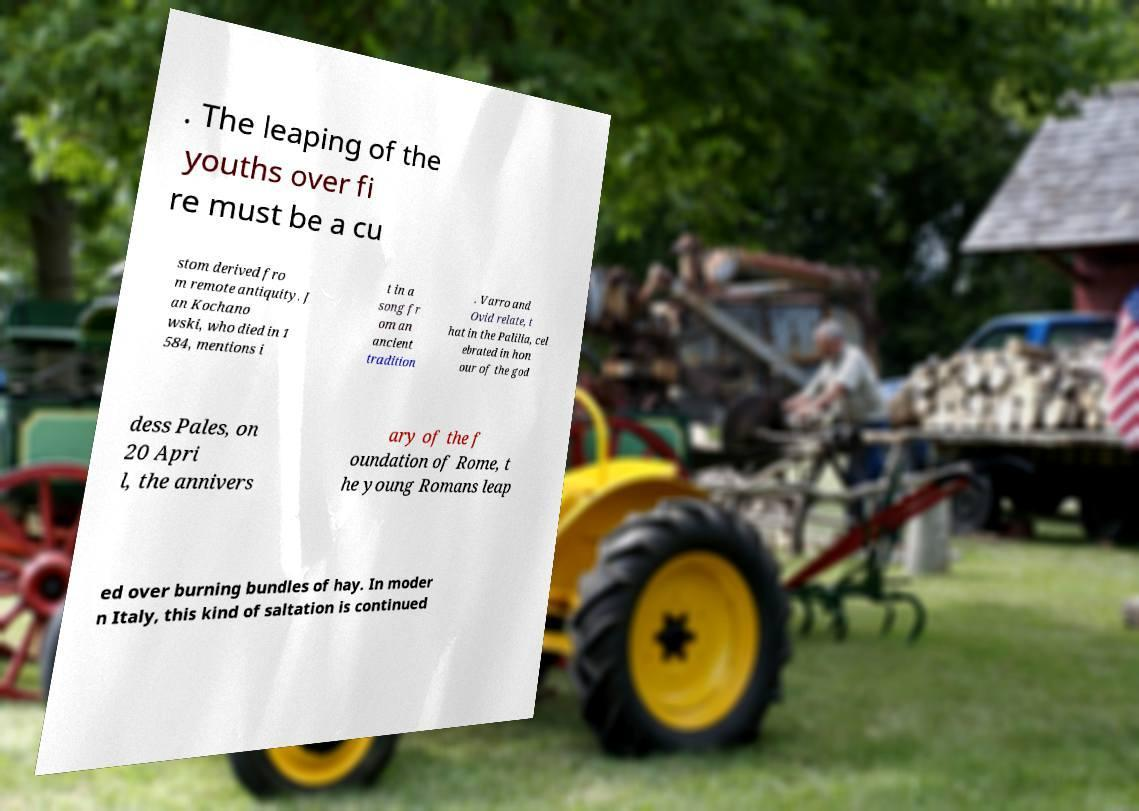Can you accurately transcribe the text from the provided image for me? . The leaping of the youths over fi re must be a cu stom derived fro m remote antiquity. J an Kochano wski, who died in 1 584, mentions i t in a song fr om an ancient tradition . Varro and Ovid relate, t hat in the Palilia, cel ebrated in hon our of the god dess Pales, on 20 Apri l, the annivers ary of the f oundation of Rome, t he young Romans leap ed over burning bundles of hay. In moder n Italy, this kind of saltation is continued 